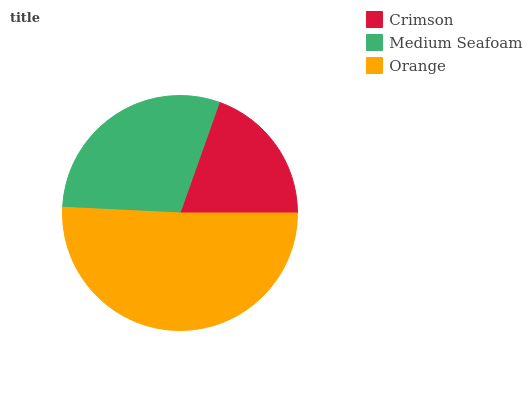Is Crimson the minimum?
Answer yes or no. Yes. Is Orange the maximum?
Answer yes or no. Yes. Is Medium Seafoam the minimum?
Answer yes or no. No. Is Medium Seafoam the maximum?
Answer yes or no. No. Is Medium Seafoam greater than Crimson?
Answer yes or no. Yes. Is Crimson less than Medium Seafoam?
Answer yes or no. Yes. Is Crimson greater than Medium Seafoam?
Answer yes or no. No. Is Medium Seafoam less than Crimson?
Answer yes or no. No. Is Medium Seafoam the high median?
Answer yes or no. Yes. Is Medium Seafoam the low median?
Answer yes or no. Yes. Is Orange the high median?
Answer yes or no. No. Is Orange the low median?
Answer yes or no. No. 